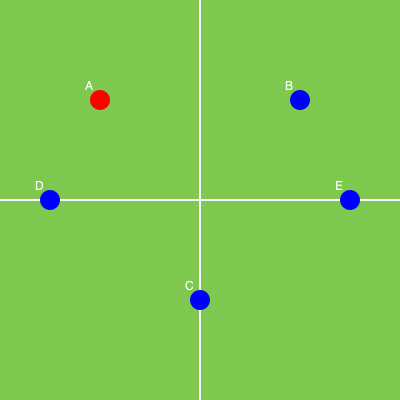Given the player positions on the field as shown in the diagram, where player A (in red) has possession of the ball, which sequence of passes would be the most efficient to reach player E while maintaining possession and creating space? To determine the most efficient passing route, we need to consider the following factors:
1. Minimize the number of passes to reduce the risk of interception.
2. Utilize triangular passing patterns to create space and maintain possession.
3. Consider the angles and distances between players to ensure accurate passes.

Let's analyze the possible routes:

1. A → B → E: This route involves two long passes, which may be risky and easier to intercept.

2. A → D → E: While this route also involves two passes, the first pass (A → D) is shorter and safer. However, the second pass (D → E) is a long diagonal pass that may be challenging.

3. A → D → C → E: This route creates a triangular passing pattern, which is excellent for maintaining possession. It also involves shorter, more manageable passes. The sequence goes as follows:
   a. A passes to D (short, safe pass)
   b. D passes to C (diagonal pass, creating space in the center)
   c. C passes to E (utilizing the space created by the previous passes)

4. A → B → C → E: While this route also creates a triangle, it involves a long initial pass from A to B, which may be riskier.

The most efficient route is option 3 (A → D → C → E) because it:
- Utilizes shorter, safer passes
- Creates a triangular passing pattern
- Maintains possession while creating space in the center of the field
- Allows for progressive movement towards the target player (E)
Answer: A → D → C → E 